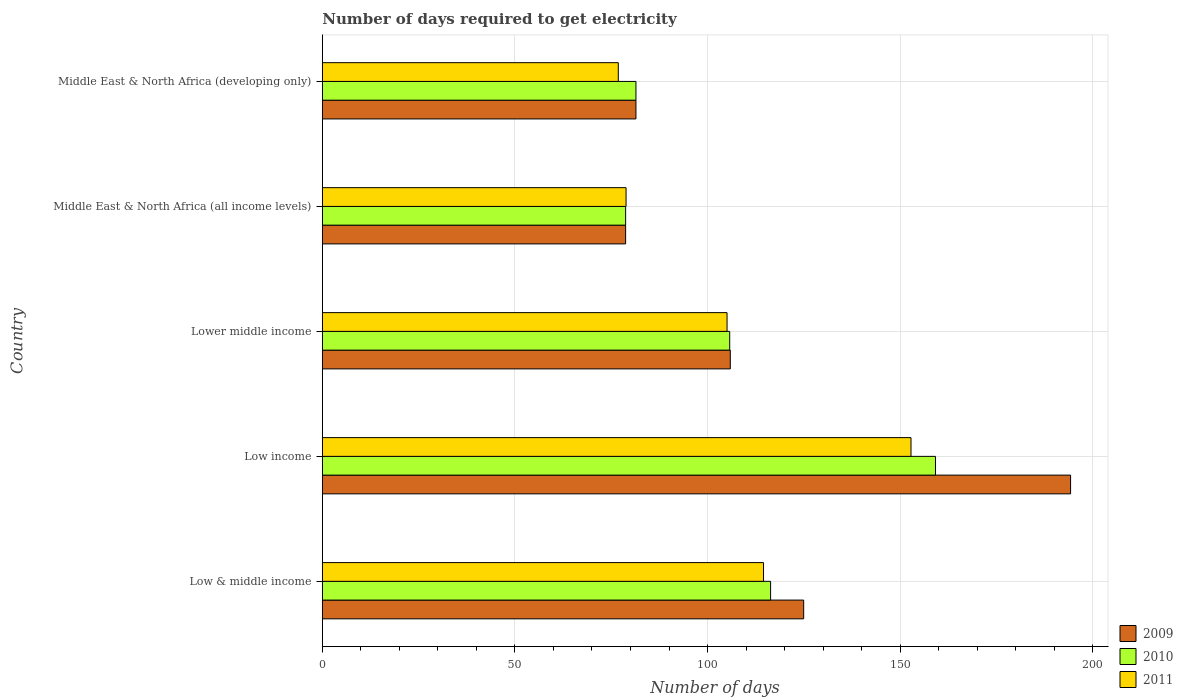How many groups of bars are there?
Provide a short and direct response. 5. Are the number of bars on each tick of the Y-axis equal?
Ensure brevity in your answer.  Yes. What is the label of the 4th group of bars from the top?
Your answer should be compact. Low income. What is the number of days required to get electricity in in 2011 in Low income?
Offer a terse response. 152.82. Across all countries, what is the maximum number of days required to get electricity in in 2009?
Keep it short and to the point. 194.25. Across all countries, what is the minimum number of days required to get electricity in in 2011?
Provide a succinct answer. 76.83. In which country was the number of days required to get electricity in in 2011 minimum?
Ensure brevity in your answer.  Middle East & North Africa (developing only). What is the total number of days required to get electricity in in 2009 in the graph?
Offer a very short reply. 585.27. What is the difference between the number of days required to get electricity in in 2011 in Low & middle income and that in Low income?
Make the answer very short. -38.29. What is the difference between the number of days required to get electricity in in 2011 in Middle East & North Africa (developing only) and the number of days required to get electricity in in 2010 in Low & middle income?
Ensure brevity in your answer.  -39.54. What is the average number of days required to get electricity in in 2009 per country?
Your answer should be compact. 117.05. What is the difference between the number of days required to get electricity in in 2010 and number of days required to get electricity in in 2009 in Lower middle income?
Ensure brevity in your answer.  -0.16. In how many countries, is the number of days required to get electricity in in 2011 greater than 10 days?
Your answer should be compact. 5. What is the ratio of the number of days required to get electricity in in 2009 in Low income to that in Middle East & North Africa (developing only)?
Ensure brevity in your answer.  2.39. Is the number of days required to get electricity in in 2010 in Low & middle income less than that in Middle East & North Africa (developing only)?
Keep it short and to the point. No. What is the difference between the highest and the second highest number of days required to get electricity in in 2010?
Your answer should be very brief. 42.81. What is the difference between the highest and the lowest number of days required to get electricity in in 2010?
Make the answer very short. 80.44. In how many countries, is the number of days required to get electricity in in 2009 greater than the average number of days required to get electricity in in 2009 taken over all countries?
Provide a short and direct response. 2. What does the 1st bar from the top in Low & middle income represents?
Provide a succinct answer. 2011. What does the 2nd bar from the bottom in Low income represents?
Give a very brief answer. 2010. Are all the bars in the graph horizontal?
Your answer should be compact. Yes. How many countries are there in the graph?
Your response must be concise. 5. What is the difference between two consecutive major ticks on the X-axis?
Provide a short and direct response. 50. Are the values on the major ticks of X-axis written in scientific E-notation?
Provide a succinct answer. No. What is the title of the graph?
Keep it short and to the point. Number of days required to get electricity. Does "2012" appear as one of the legend labels in the graph?
Keep it short and to the point. No. What is the label or title of the X-axis?
Your response must be concise. Number of days. What is the label or title of the Y-axis?
Offer a very short reply. Country. What is the Number of days in 2009 in Low & middle income?
Your answer should be compact. 124.96. What is the Number of days in 2010 in Low & middle income?
Your answer should be compact. 116.37. What is the Number of days in 2011 in Low & middle income?
Offer a very short reply. 114.53. What is the Number of days in 2009 in Low income?
Provide a succinct answer. 194.25. What is the Number of days in 2010 in Low income?
Give a very brief answer. 159.18. What is the Number of days of 2011 in Low income?
Offer a very short reply. 152.82. What is the Number of days in 2009 in Lower middle income?
Your answer should be compact. 105.91. What is the Number of days in 2010 in Lower middle income?
Provide a short and direct response. 105.76. What is the Number of days in 2011 in Lower middle income?
Keep it short and to the point. 105.07. What is the Number of days of 2009 in Middle East & North Africa (all income levels)?
Offer a terse response. 78.74. What is the Number of days in 2010 in Middle East & North Africa (all income levels)?
Provide a short and direct response. 78.74. What is the Number of days in 2011 in Middle East & North Africa (all income levels)?
Ensure brevity in your answer.  78.85. What is the Number of days of 2009 in Middle East & North Africa (developing only)?
Keep it short and to the point. 81.42. What is the Number of days of 2010 in Middle East & North Africa (developing only)?
Offer a very short reply. 81.42. What is the Number of days in 2011 in Middle East & North Africa (developing only)?
Your answer should be very brief. 76.83. Across all countries, what is the maximum Number of days in 2009?
Offer a terse response. 194.25. Across all countries, what is the maximum Number of days in 2010?
Offer a terse response. 159.18. Across all countries, what is the maximum Number of days of 2011?
Offer a terse response. 152.82. Across all countries, what is the minimum Number of days in 2009?
Offer a very short reply. 78.74. Across all countries, what is the minimum Number of days of 2010?
Offer a very short reply. 78.74. Across all countries, what is the minimum Number of days in 2011?
Provide a succinct answer. 76.83. What is the total Number of days in 2009 in the graph?
Make the answer very short. 585.27. What is the total Number of days of 2010 in the graph?
Your answer should be very brief. 541.46. What is the total Number of days of 2011 in the graph?
Your response must be concise. 528.11. What is the difference between the Number of days in 2009 in Low & middle income and that in Low income?
Make the answer very short. -69.29. What is the difference between the Number of days of 2010 in Low & middle income and that in Low income?
Give a very brief answer. -42.81. What is the difference between the Number of days in 2011 in Low & middle income and that in Low income?
Keep it short and to the point. -38.29. What is the difference between the Number of days of 2009 in Low & middle income and that in Lower middle income?
Provide a succinct answer. 19.05. What is the difference between the Number of days of 2010 in Low & middle income and that in Lower middle income?
Keep it short and to the point. 10.62. What is the difference between the Number of days of 2011 in Low & middle income and that in Lower middle income?
Ensure brevity in your answer.  9.47. What is the difference between the Number of days of 2009 in Low & middle income and that in Middle East & North Africa (all income levels)?
Provide a short and direct response. 46.22. What is the difference between the Number of days in 2010 in Low & middle income and that in Middle East & North Africa (all income levels)?
Your answer should be very brief. 37.64. What is the difference between the Number of days in 2011 in Low & middle income and that in Middle East & North Africa (all income levels)?
Your answer should be very brief. 35.68. What is the difference between the Number of days of 2009 in Low & middle income and that in Middle East & North Africa (developing only)?
Offer a terse response. 43.54. What is the difference between the Number of days in 2010 in Low & middle income and that in Middle East & North Africa (developing only)?
Your answer should be very brief. 34.96. What is the difference between the Number of days of 2011 in Low & middle income and that in Middle East & North Africa (developing only)?
Your response must be concise. 37.7. What is the difference between the Number of days in 2009 in Low income and that in Lower middle income?
Your answer should be very brief. 88.34. What is the difference between the Number of days in 2010 in Low income and that in Lower middle income?
Offer a terse response. 53.42. What is the difference between the Number of days of 2011 in Low income and that in Lower middle income?
Offer a terse response. 47.75. What is the difference between the Number of days in 2009 in Low income and that in Middle East & North Africa (all income levels)?
Your response must be concise. 115.51. What is the difference between the Number of days of 2010 in Low income and that in Middle East & North Africa (all income levels)?
Provide a succinct answer. 80.44. What is the difference between the Number of days in 2011 in Low income and that in Middle East & North Africa (all income levels)?
Your answer should be compact. 73.97. What is the difference between the Number of days in 2009 in Low income and that in Middle East & North Africa (developing only)?
Offer a terse response. 112.83. What is the difference between the Number of days in 2010 in Low income and that in Middle East & North Africa (developing only)?
Your answer should be very brief. 77.76. What is the difference between the Number of days of 2011 in Low income and that in Middle East & North Africa (developing only)?
Ensure brevity in your answer.  75.99. What is the difference between the Number of days in 2009 in Lower middle income and that in Middle East & North Africa (all income levels)?
Your answer should be very brief. 27.17. What is the difference between the Number of days in 2010 in Lower middle income and that in Middle East & North Africa (all income levels)?
Your response must be concise. 27.02. What is the difference between the Number of days in 2011 in Lower middle income and that in Middle East & North Africa (all income levels)?
Keep it short and to the point. 26.22. What is the difference between the Number of days of 2009 in Lower middle income and that in Middle East & North Africa (developing only)?
Your answer should be very brief. 24.49. What is the difference between the Number of days of 2010 in Lower middle income and that in Middle East & North Africa (developing only)?
Ensure brevity in your answer.  24.34. What is the difference between the Number of days of 2011 in Lower middle income and that in Middle East & North Africa (developing only)?
Offer a terse response. 28.23. What is the difference between the Number of days in 2009 in Middle East & North Africa (all income levels) and that in Middle East & North Africa (developing only)?
Your response must be concise. -2.68. What is the difference between the Number of days of 2010 in Middle East & North Africa (all income levels) and that in Middle East & North Africa (developing only)?
Your answer should be very brief. -2.68. What is the difference between the Number of days in 2011 in Middle East & North Africa (all income levels) and that in Middle East & North Africa (developing only)?
Your response must be concise. 2.02. What is the difference between the Number of days of 2009 in Low & middle income and the Number of days of 2010 in Low income?
Keep it short and to the point. -34.22. What is the difference between the Number of days in 2009 in Low & middle income and the Number of days in 2011 in Low income?
Your response must be concise. -27.86. What is the difference between the Number of days of 2010 in Low & middle income and the Number of days of 2011 in Low income?
Keep it short and to the point. -36.45. What is the difference between the Number of days of 2009 in Low & middle income and the Number of days of 2010 in Lower middle income?
Give a very brief answer. 19.2. What is the difference between the Number of days of 2009 in Low & middle income and the Number of days of 2011 in Lower middle income?
Keep it short and to the point. 19.89. What is the difference between the Number of days in 2010 in Low & middle income and the Number of days in 2011 in Lower middle income?
Your response must be concise. 11.31. What is the difference between the Number of days of 2009 in Low & middle income and the Number of days of 2010 in Middle East & North Africa (all income levels)?
Ensure brevity in your answer.  46.22. What is the difference between the Number of days of 2009 in Low & middle income and the Number of days of 2011 in Middle East & North Africa (all income levels)?
Offer a very short reply. 46.11. What is the difference between the Number of days of 2010 in Low & middle income and the Number of days of 2011 in Middle East & North Africa (all income levels)?
Keep it short and to the point. 37.52. What is the difference between the Number of days in 2009 in Low & middle income and the Number of days in 2010 in Middle East & North Africa (developing only)?
Your response must be concise. 43.54. What is the difference between the Number of days in 2009 in Low & middle income and the Number of days in 2011 in Middle East & North Africa (developing only)?
Keep it short and to the point. 48.12. What is the difference between the Number of days in 2010 in Low & middle income and the Number of days in 2011 in Middle East & North Africa (developing only)?
Provide a short and direct response. 39.54. What is the difference between the Number of days of 2009 in Low income and the Number of days of 2010 in Lower middle income?
Give a very brief answer. 88.49. What is the difference between the Number of days in 2009 in Low income and the Number of days in 2011 in Lower middle income?
Ensure brevity in your answer.  89.18. What is the difference between the Number of days in 2010 in Low income and the Number of days in 2011 in Lower middle income?
Your answer should be compact. 54.11. What is the difference between the Number of days in 2009 in Low income and the Number of days in 2010 in Middle East & North Africa (all income levels)?
Offer a terse response. 115.51. What is the difference between the Number of days in 2009 in Low income and the Number of days in 2011 in Middle East & North Africa (all income levels)?
Your answer should be compact. 115.4. What is the difference between the Number of days of 2010 in Low income and the Number of days of 2011 in Middle East & North Africa (all income levels)?
Your answer should be very brief. 80.33. What is the difference between the Number of days of 2009 in Low income and the Number of days of 2010 in Middle East & North Africa (developing only)?
Offer a terse response. 112.83. What is the difference between the Number of days in 2009 in Low income and the Number of days in 2011 in Middle East & North Africa (developing only)?
Keep it short and to the point. 117.42. What is the difference between the Number of days in 2010 in Low income and the Number of days in 2011 in Middle East & North Africa (developing only)?
Provide a short and direct response. 82.35. What is the difference between the Number of days in 2009 in Lower middle income and the Number of days in 2010 in Middle East & North Africa (all income levels)?
Keep it short and to the point. 27.17. What is the difference between the Number of days in 2009 in Lower middle income and the Number of days in 2011 in Middle East & North Africa (all income levels)?
Your answer should be compact. 27.06. What is the difference between the Number of days in 2010 in Lower middle income and the Number of days in 2011 in Middle East & North Africa (all income levels)?
Keep it short and to the point. 26.91. What is the difference between the Number of days of 2009 in Lower middle income and the Number of days of 2010 in Middle East & North Africa (developing only)?
Your response must be concise. 24.49. What is the difference between the Number of days in 2009 in Lower middle income and the Number of days in 2011 in Middle East & North Africa (developing only)?
Offer a very short reply. 29.08. What is the difference between the Number of days in 2010 in Lower middle income and the Number of days in 2011 in Middle East & North Africa (developing only)?
Provide a short and direct response. 28.92. What is the difference between the Number of days in 2009 in Middle East & North Africa (all income levels) and the Number of days in 2010 in Middle East & North Africa (developing only)?
Offer a terse response. -2.68. What is the difference between the Number of days in 2009 in Middle East & North Africa (all income levels) and the Number of days in 2011 in Middle East & North Africa (developing only)?
Provide a succinct answer. 1.9. What is the difference between the Number of days in 2010 in Middle East & North Africa (all income levels) and the Number of days in 2011 in Middle East & North Africa (developing only)?
Give a very brief answer. 1.9. What is the average Number of days of 2009 per country?
Offer a very short reply. 117.05. What is the average Number of days in 2010 per country?
Your answer should be compact. 108.29. What is the average Number of days in 2011 per country?
Ensure brevity in your answer.  105.62. What is the difference between the Number of days of 2009 and Number of days of 2010 in Low & middle income?
Provide a succinct answer. 8.58. What is the difference between the Number of days of 2009 and Number of days of 2011 in Low & middle income?
Your answer should be compact. 10.42. What is the difference between the Number of days of 2010 and Number of days of 2011 in Low & middle income?
Make the answer very short. 1.84. What is the difference between the Number of days in 2009 and Number of days in 2010 in Low income?
Your answer should be compact. 35.07. What is the difference between the Number of days of 2009 and Number of days of 2011 in Low income?
Provide a short and direct response. 41.43. What is the difference between the Number of days in 2010 and Number of days in 2011 in Low income?
Ensure brevity in your answer.  6.36. What is the difference between the Number of days in 2009 and Number of days in 2010 in Lower middle income?
Your answer should be very brief. 0.16. What is the difference between the Number of days of 2009 and Number of days of 2011 in Lower middle income?
Make the answer very short. 0.84. What is the difference between the Number of days in 2010 and Number of days in 2011 in Lower middle income?
Your response must be concise. 0.69. What is the difference between the Number of days of 2009 and Number of days of 2011 in Middle East & North Africa (all income levels)?
Your answer should be very brief. -0.11. What is the difference between the Number of days of 2010 and Number of days of 2011 in Middle East & North Africa (all income levels)?
Give a very brief answer. -0.11. What is the difference between the Number of days in 2009 and Number of days in 2010 in Middle East & North Africa (developing only)?
Offer a terse response. 0. What is the difference between the Number of days in 2009 and Number of days in 2011 in Middle East & North Africa (developing only)?
Your answer should be very brief. 4.58. What is the difference between the Number of days of 2010 and Number of days of 2011 in Middle East & North Africa (developing only)?
Offer a terse response. 4.58. What is the ratio of the Number of days of 2009 in Low & middle income to that in Low income?
Offer a terse response. 0.64. What is the ratio of the Number of days of 2010 in Low & middle income to that in Low income?
Make the answer very short. 0.73. What is the ratio of the Number of days of 2011 in Low & middle income to that in Low income?
Provide a succinct answer. 0.75. What is the ratio of the Number of days of 2009 in Low & middle income to that in Lower middle income?
Offer a terse response. 1.18. What is the ratio of the Number of days of 2010 in Low & middle income to that in Lower middle income?
Offer a terse response. 1.1. What is the ratio of the Number of days of 2011 in Low & middle income to that in Lower middle income?
Your answer should be very brief. 1.09. What is the ratio of the Number of days in 2009 in Low & middle income to that in Middle East & North Africa (all income levels)?
Your response must be concise. 1.59. What is the ratio of the Number of days of 2010 in Low & middle income to that in Middle East & North Africa (all income levels)?
Offer a terse response. 1.48. What is the ratio of the Number of days of 2011 in Low & middle income to that in Middle East & North Africa (all income levels)?
Keep it short and to the point. 1.45. What is the ratio of the Number of days in 2009 in Low & middle income to that in Middle East & North Africa (developing only)?
Provide a succinct answer. 1.53. What is the ratio of the Number of days of 2010 in Low & middle income to that in Middle East & North Africa (developing only)?
Provide a succinct answer. 1.43. What is the ratio of the Number of days in 2011 in Low & middle income to that in Middle East & North Africa (developing only)?
Your response must be concise. 1.49. What is the ratio of the Number of days in 2009 in Low income to that in Lower middle income?
Offer a terse response. 1.83. What is the ratio of the Number of days in 2010 in Low income to that in Lower middle income?
Ensure brevity in your answer.  1.51. What is the ratio of the Number of days of 2011 in Low income to that in Lower middle income?
Provide a short and direct response. 1.45. What is the ratio of the Number of days in 2009 in Low income to that in Middle East & North Africa (all income levels)?
Your answer should be very brief. 2.47. What is the ratio of the Number of days in 2010 in Low income to that in Middle East & North Africa (all income levels)?
Ensure brevity in your answer.  2.02. What is the ratio of the Number of days in 2011 in Low income to that in Middle East & North Africa (all income levels)?
Your answer should be compact. 1.94. What is the ratio of the Number of days of 2009 in Low income to that in Middle East & North Africa (developing only)?
Your answer should be compact. 2.39. What is the ratio of the Number of days in 2010 in Low income to that in Middle East & North Africa (developing only)?
Your answer should be very brief. 1.96. What is the ratio of the Number of days in 2011 in Low income to that in Middle East & North Africa (developing only)?
Your response must be concise. 1.99. What is the ratio of the Number of days in 2009 in Lower middle income to that in Middle East & North Africa (all income levels)?
Make the answer very short. 1.35. What is the ratio of the Number of days of 2010 in Lower middle income to that in Middle East & North Africa (all income levels)?
Provide a short and direct response. 1.34. What is the ratio of the Number of days in 2011 in Lower middle income to that in Middle East & North Africa (all income levels)?
Your answer should be very brief. 1.33. What is the ratio of the Number of days in 2009 in Lower middle income to that in Middle East & North Africa (developing only)?
Provide a short and direct response. 1.3. What is the ratio of the Number of days of 2010 in Lower middle income to that in Middle East & North Africa (developing only)?
Your response must be concise. 1.3. What is the ratio of the Number of days of 2011 in Lower middle income to that in Middle East & North Africa (developing only)?
Make the answer very short. 1.37. What is the ratio of the Number of days in 2009 in Middle East & North Africa (all income levels) to that in Middle East & North Africa (developing only)?
Offer a very short reply. 0.97. What is the ratio of the Number of days in 2010 in Middle East & North Africa (all income levels) to that in Middle East & North Africa (developing only)?
Offer a terse response. 0.97. What is the ratio of the Number of days in 2011 in Middle East & North Africa (all income levels) to that in Middle East & North Africa (developing only)?
Provide a succinct answer. 1.03. What is the difference between the highest and the second highest Number of days in 2009?
Keep it short and to the point. 69.29. What is the difference between the highest and the second highest Number of days of 2010?
Give a very brief answer. 42.81. What is the difference between the highest and the second highest Number of days of 2011?
Your response must be concise. 38.29. What is the difference between the highest and the lowest Number of days in 2009?
Give a very brief answer. 115.51. What is the difference between the highest and the lowest Number of days in 2010?
Your response must be concise. 80.44. What is the difference between the highest and the lowest Number of days in 2011?
Give a very brief answer. 75.99. 